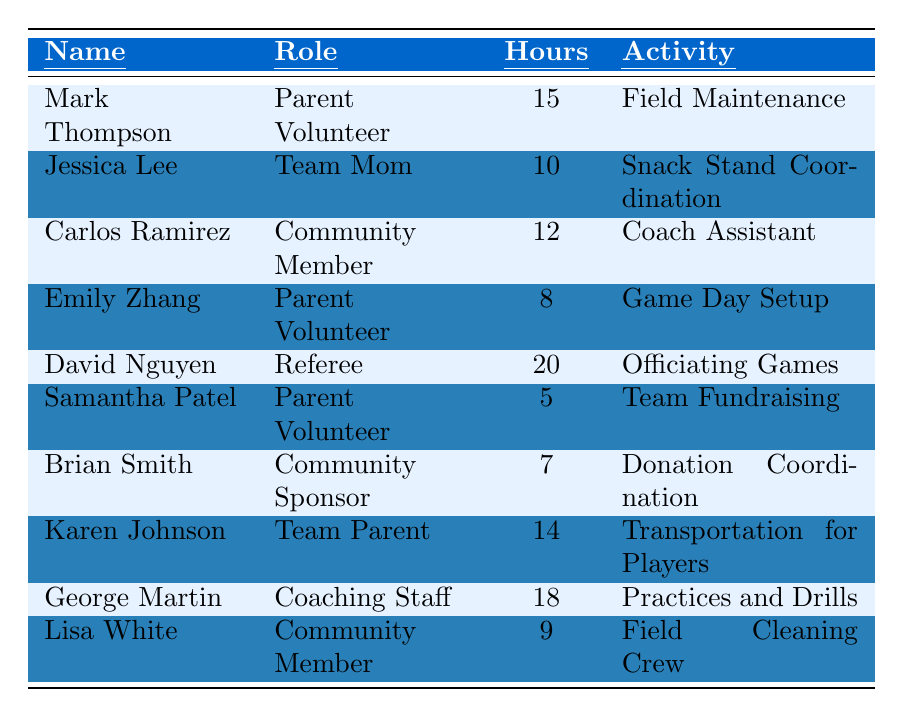What is the name of the volunteer who logged the most hours? Looking through the table, I can see that David Nguyen logged 20 hours, which is the highest among all volunteers.
Answer: David Nguyen How many hours did Jessica Lee log? In the table, Jessica Lee is listed with 10 hours.
Answer: 10 hours Who is a community member that assisted with coaching? The table shows Carlos Ramirez as a Community Member with the activity listed as Coach Assistant.
Answer: Carlos Ramirez What is the total number of volunteer hours logged by parents? The total hours for parents (Mark Thompson, Emily Zhang, Samantha Patel, and Karen Johnson) are 15 + 8 + 5 + 14 = 42 hours.
Answer: 42 hours Which activity had the least volunteer hours logged? From the table, the least hours logged is 5 hours for Team Fundraising by Samantha Patel.
Answer: Team Fundraising Did any parent volunteer log more hours than the team mom? The team mom, Jessica Lee, logged 10 hours. Other parent volunteers like Mark Thompson and Karen Johnson logged 15 and 14 hours respectively, both more than 10 hours.
Answer: Yes What is the average number of hours logged by volunteer parents? Summing the hours from the four volunteers (Mark Thompson, Emily Zhang, Samantha Patel, Karen Johnson) gives 15 + 8 + 5 + 14 = 42 hours. Dividing by 4 gives 42/4 = 10.5 hours.
Answer: 10.5 hours How many more hours did George Martin log than Lisa White? George Martin logged 18 hours while Lisa White logged 9 hours; the difference is 18 - 9 = 9 hours.
Answer: 9 hours Is there any volunteer who has logged exactly 12 hours? The table shows Carlos Ramirez with 12 hours, confirming there is indeed a volunteer that logged this exact amount.
Answer: Yes What is the combined total of hours logged by community members? The community members are Carlos Ramirez (12 hours), Brian Smith (7 hours), and Lisa White (9 hours). Their total is 12 + 7 + 9 = 28 hours.
Answer: 28 hours 